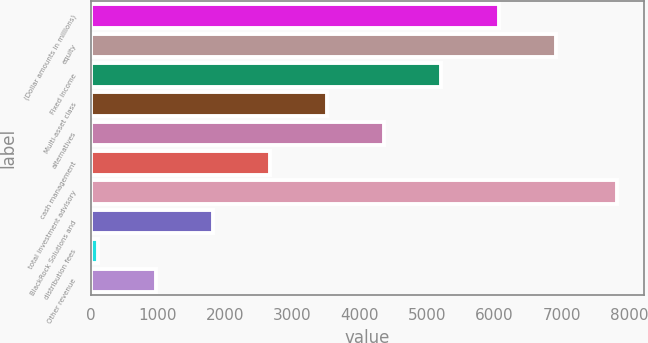<chart> <loc_0><loc_0><loc_500><loc_500><bar_chart><fcel>(Dollar amounts in millions)<fcel>equity<fcel>Fixed income<fcel>Multi-asset class<fcel>alternatives<fcel>cash management<fcel>total investment advisory<fcel>BlackRock Solutions and<fcel>distribution fees<fcel>Other revenue<nl><fcel>6063.2<fcel>6912.8<fcel>5213.6<fcel>3514.4<fcel>4364<fcel>2664.8<fcel>7830<fcel>1815.2<fcel>116<fcel>965.6<nl></chart> 